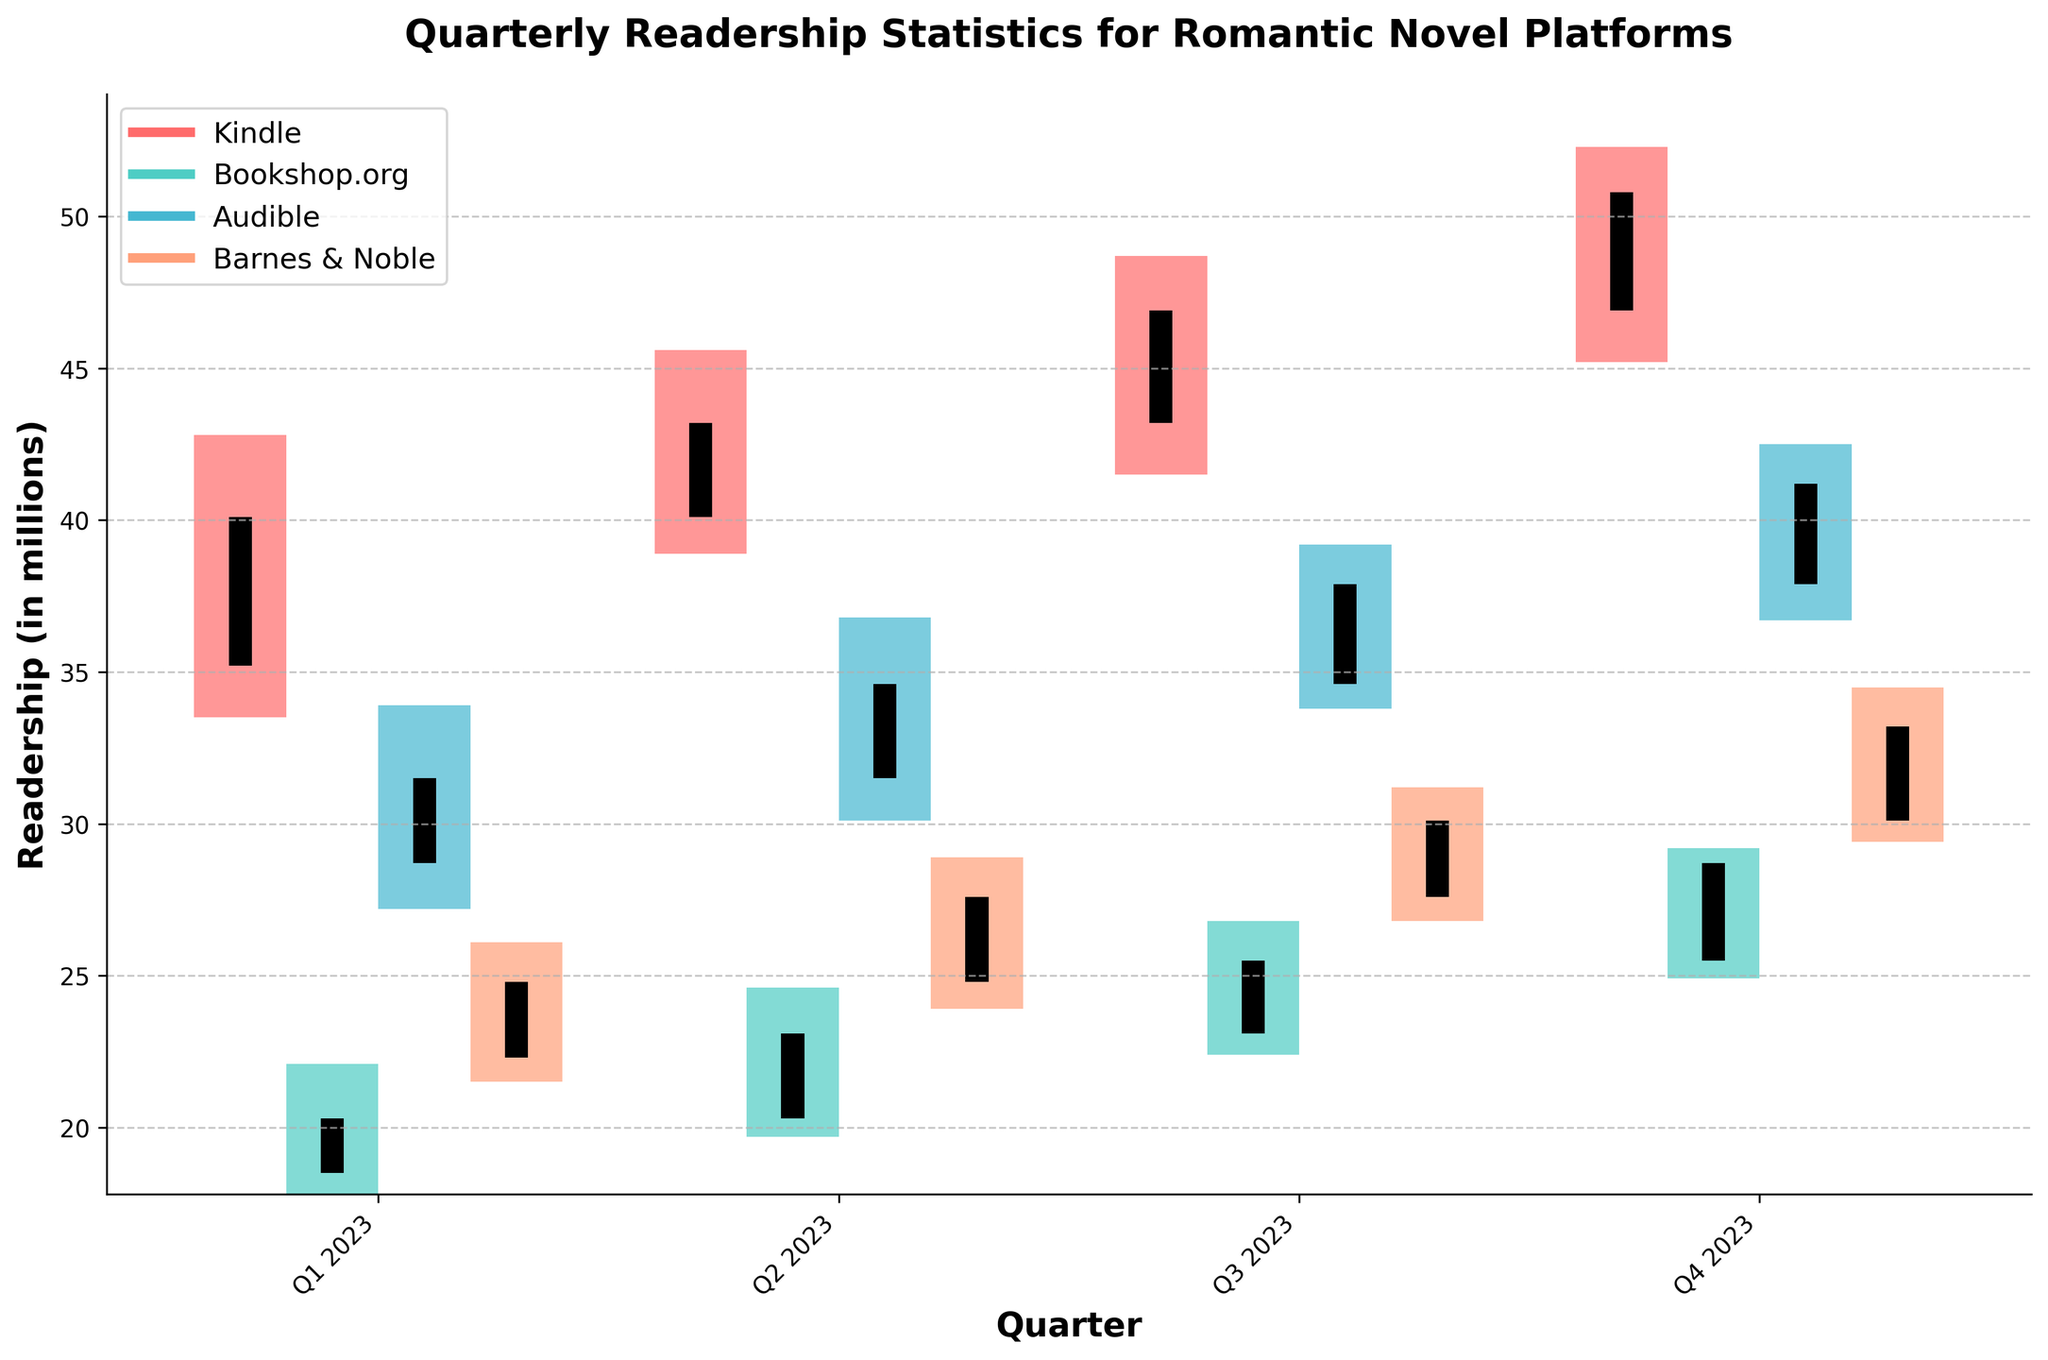What is the title of the graph? The title is usually written at the top of the graph, and in this case, it reads "Quarterly Readership Statistics for Romantic Novel Platforms".
Answer: Quarterly Readership Statistics for Romantic Novel Platforms What are the platforms compared in the graph? By looking at the legend, you can see the names of the platforms which are Kindle, Bookshop.org, Audible, and Barnes & Noble.
Answer: Kindle, Bookshop.org, Audible, Barnes & Noble Which platform showed the highest readership in Q4 2023? From the visual data, Kindle has the highest close value (50.8) in Q4 2023 among all the platforms.
Answer: Kindle Which quarter had the lowest opening readership for Bookshop.org? By comparing the opening values across all quarters for Bookshop.org, Q1 2023 has the lowest opening readership (18.5).
Answer: Q1 2023 What is the difference between the high and low values for Audible in Q2 2023? In Q2 2023, Audible's high value is 36.8 and the low value is 30.1, so the difference is 36.8 - 30.1 = 6.7.
Answer: 6.7 Which platform had the lowest close value in Q1 2023? By comparing the close values in Q1 2023, Bookshop.org had the lowest close value (20.3).
Answer: Bookshop.org What is the average close value for Barnes & Noble over the four quarters in 2023? Add the close values for all four quarters for Barnes & Noble (24.8 + 27.6 + 30.1 + 33.2) and divide by 4: (24.8 + 27.6 + 30.1 + 33.2) / 4 = 28.925.
Answer: 28.925 In which quarter did Kindle have the smallest range between its high and low values? The range between high and low values for each quarter for Kindle is calculated, and Q1 2023 has the smallest range (42.8 - 33.5 = 9.3).
Answer: Q1 2023 Which two platforms had the closest readership values in Q3 2023? In Q3 2023, by comparing the close values and checking the differences, Bookshop.org (25.5) and Audible (37.9) had close readership values.
Answer: Bookshop.org and Audible Which platform shows the most consistent increase in its readership from Q1 to Q4 in 2023? Kindle shows a consistent increase in its close values from Q1 (40.1) to Q4 (50.8) 2023 without any dips.
Answer: Kindle 